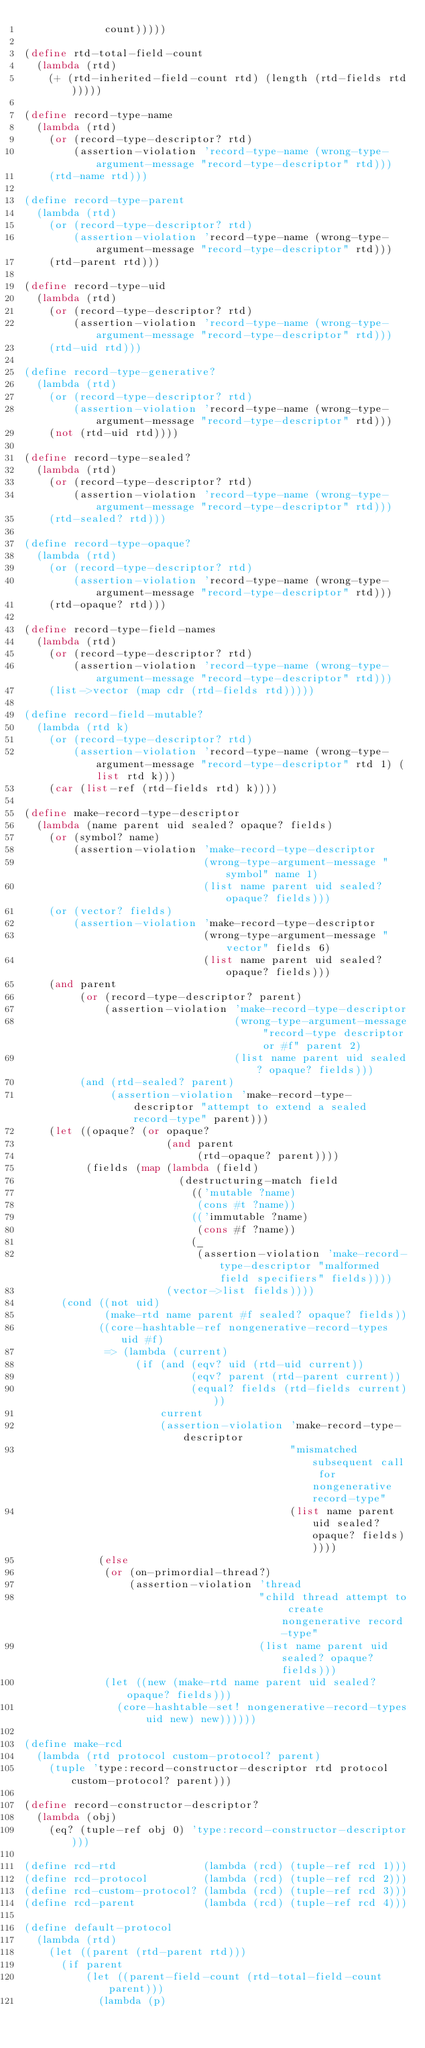Convert code to text. <code><loc_0><loc_0><loc_500><loc_500><_Scheme_>             count)))))

(define rtd-total-field-count
  (lambda (rtd)
    (+ (rtd-inherited-field-count rtd) (length (rtd-fields rtd)))))

(define record-type-name
  (lambda (rtd)
    (or (record-type-descriptor? rtd)
        (assertion-violation 'record-type-name (wrong-type-argument-message "record-type-descriptor" rtd)))
    (rtd-name rtd)))

(define record-type-parent
  (lambda (rtd)
    (or (record-type-descriptor? rtd)
        (assertion-violation 'record-type-name (wrong-type-argument-message "record-type-descriptor" rtd)))
    (rtd-parent rtd)))

(define record-type-uid
  (lambda (rtd)
    (or (record-type-descriptor? rtd)
        (assertion-violation 'record-type-name (wrong-type-argument-message "record-type-descriptor" rtd)))
    (rtd-uid rtd)))

(define record-type-generative?
  (lambda (rtd)
    (or (record-type-descriptor? rtd)
        (assertion-violation 'record-type-name (wrong-type-argument-message "record-type-descriptor" rtd)))
    (not (rtd-uid rtd))))

(define record-type-sealed?
  (lambda (rtd)
    (or (record-type-descriptor? rtd)
        (assertion-violation 'record-type-name (wrong-type-argument-message "record-type-descriptor" rtd)))
    (rtd-sealed? rtd)))

(define record-type-opaque?
  (lambda (rtd)
    (or (record-type-descriptor? rtd)
        (assertion-violation 'record-type-name (wrong-type-argument-message "record-type-descriptor" rtd)))
    (rtd-opaque? rtd)))

(define record-type-field-names
  (lambda (rtd)
    (or (record-type-descriptor? rtd)
        (assertion-violation 'record-type-name (wrong-type-argument-message "record-type-descriptor" rtd)))
    (list->vector (map cdr (rtd-fields rtd)))))

(define record-field-mutable?
  (lambda (rtd k)
    (or (record-type-descriptor? rtd)
        (assertion-violation 'record-type-name (wrong-type-argument-message "record-type-descriptor" rtd 1) (list rtd k)))
    (car (list-ref (rtd-fields rtd) k))))

(define make-record-type-descriptor
  (lambda (name parent uid sealed? opaque? fields)
    (or (symbol? name)
        (assertion-violation 'make-record-type-descriptor
                             (wrong-type-argument-message "symbol" name 1)
                             (list name parent uid sealed? opaque? fields)))
    (or (vector? fields)
        (assertion-violation 'make-record-type-descriptor
                             (wrong-type-argument-message "vector" fields 6)
                             (list name parent uid sealed? opaque? fields)))
    (and parent
         (or (record-type-descriptor? parent)
             (assertion-violation 'make-record-type-descriptor
                                  (wrong-type-argument-message "record-type descriptor or #f" parent 2)
                                  (list name parent uid sealed? opaque? fields)))
         (and (rtd-sealed? parent)
              (assertion-violation 'make-record-type-descriptor "attempt to extend a sealed record-type" parent)))
    (let ((opaque? (or opaque?
                       (and parent
                            (rtd-opaque? parent))))
          (fields (map (lambda (field)
                         (destructuring-match field
                           (('mutable ?name)
                            (cons #t ?name))
                           (('immutable ?name)
                            (cons #f ?name))
                           (_
                            (assertion-violation 'make-record-type-descriptor "malformed field specifiers" fields))))
                       (vector->list fields))))
      (cond ((not uid)
             (make-rtd name parent #f sealed? opaque? fields))
            ((core-hashtable-ref nongenerative-record-types uid #f)
             => (lambda (current)
                  (if (and (eqv? uid (rtd-uid current))
                           (eqv? parent (rtd-parent current))
                           (equal? fields (rtd-fields current)))
                      current
                      (assertion-violation 'make-record-type-descriptor
                                           "mismatched subsequent call for nongenerative record-type"
                                           (list name parent uid sealed? opaque? fields)))))
            (else
             (or (on-primordial-thread?)
                 (assertion-violation 'thread
                                      "child thread attempt to create nongenerative record-type"
                                      (list name parent uid sealed? opaque? fields)))
             (let ((new (make-rtd name parent uid sealed? opaque? fields)))
               (core-hashtable-set! nongenerative-record-types uid new) new))))))

(define make-rcd
  (lambda (rtd protocol custom-protocol? parent)
    (tuple 'type:record-constructor-descriptor rtd protocol custom-protocol? parent)))

(define record-constructor-descriptor?
  (lambda (obj)
    (eq? (tuple-ref obj 0) 'type:record-constructor-descriptor)))

(define rcd-rtd              (lambda (rcd) (tuple-ref rcd 1)))
(define rcd-protocol         (lambda (rcd) (tuple-ref rcd 2)))
(define rcd-custom-protocol? (lambda (rcd) (tuple-ref rcd 3)))
(define rcd-parent           (lambda (rcd) (tuple-ref rcd 4)))

(define default-protocol
  (lambda (rtd)
    (let ((parent (rtd-parent rtd)))
      (if parent
          (let ((parent-field-count (rtd-total-field-count parent)))
            (lambda (p)</code> 